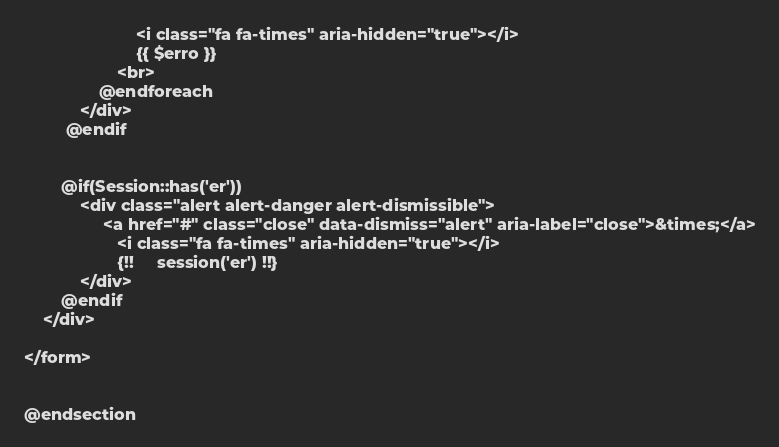Convert code to text. <code><loc_0><loc_0><loc_500><loc_500><_PHP_>						<i class="fa fa-times" aria-hidden="true"></i>
						{{ $erro }}
					<br>
    			@endforeach
			</div>
   		 @endif
	      
			
		@if(Session::has('er'))
    		<div class="alert alert-danger alert-dismissible">
				 <a href="#" class="close" data-dismiss="alert" aria-label="close">&times;</a>
					<i class="fa fa-times" aria-hidden="true"></i>
	    			{!! 	session('er') !!}
    		</div>
		@endif
	</div>

</form>


@endsection</code> 